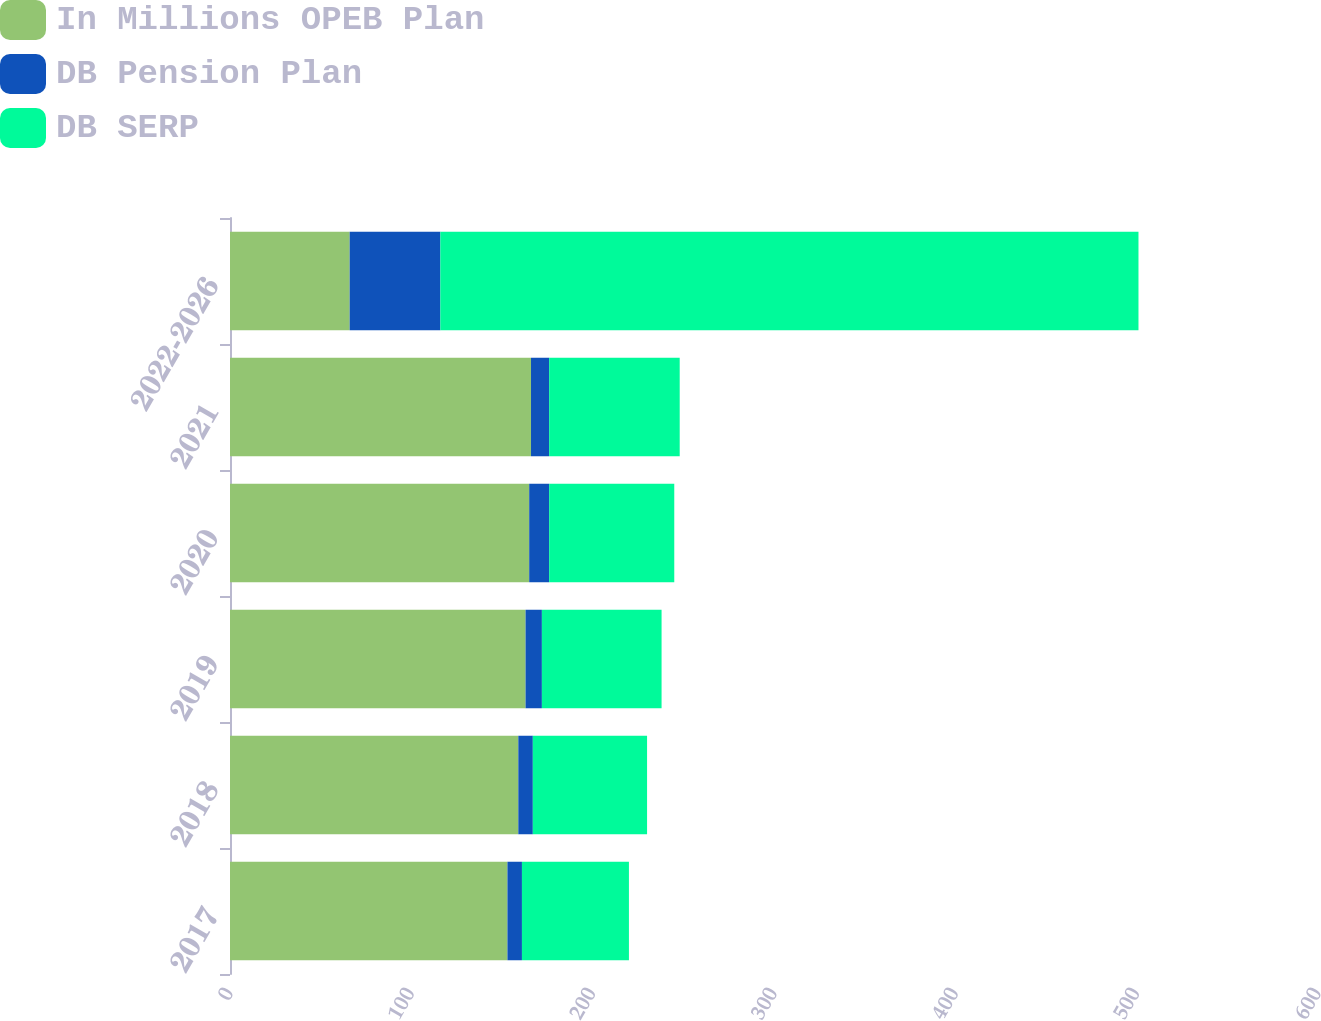Convert chart. <chart><loc_0><loc_0><loc_500><loc_500><stacked_bar_chart><ecel><fcel>2017<fcel>2018<fcel>2019<fcel>2020<fcel>2021<fcel>2022-2026<nl><fcel>In Millions OPEB Plan<fcel>153<fcel>159<fcel>163<fcel>165<fcel>166<fcel>66<nl><fcel>DB Pension Plan<fcel>8<fcel>8<fcel>9<fcel>11<fcel>10<fcel>50<nl><fcel>DB SERP<fcel>59<fcel>63<fcel>66<fcel>69<fcel>72<fcel>385<nl></chart> 